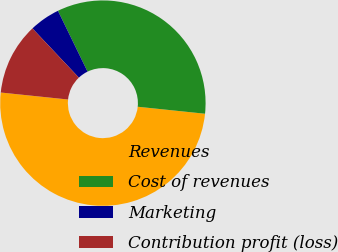Convert chart. <chart><loc_0><loc_0><loc_500><loc_500><pie_chart><fcel>Revenues<fcel>Cost of revenues<fcel>Marketing<fcel>Contribution profit (loss)<nl><fcel>50.0%<fcel>33.86%<fcel>4.82%<fcel>11.32%<nl></chart> 